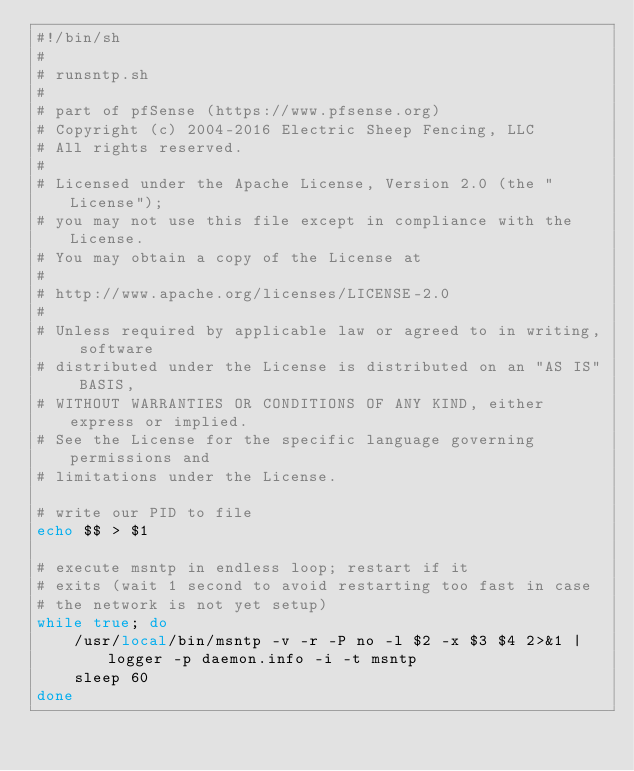<code> <loc_0><loc_0><loc_500><loc_500><_Bash_>#!/bin/sh
#
# runsntp.sh
#
# part of pfSense (https://www.pfsense.org)
# Copyright (c) 2004-2016 Electric Sheep Fencing, LLC
# All rights reserved.
#
# Licensed under the Apache License, Version 2.0 (the "License");
# you may not use this file except in compliance with the License.
# You may obtain a copy of the License at
#
# http://www.apache.org/licenses/LICENSE-2.0
#
# Unless required by applicable law or agreed to in writing, software
# distributed under the License is distributed on an "AS IS" BASIS,
# WITHOUT WARRANTIES OR CONDITIONS OF ANY KIND, either express or implied.
# See the License for the specific language governing permissions and
# limitations under the License.

# write our PID to file
echo $$ > $1

# execute msntp in endless loop; restart if it
# exits (wait 1 second to avoid restarting too fast in case
# the network is not yet setup)
while true; do
	/usr/local/bin/msntp -v -r -P no -l $2 -x $3 $4 2>&1 | logger -p daemon.info -i -t msntp
	sleep 60
done
</code> 